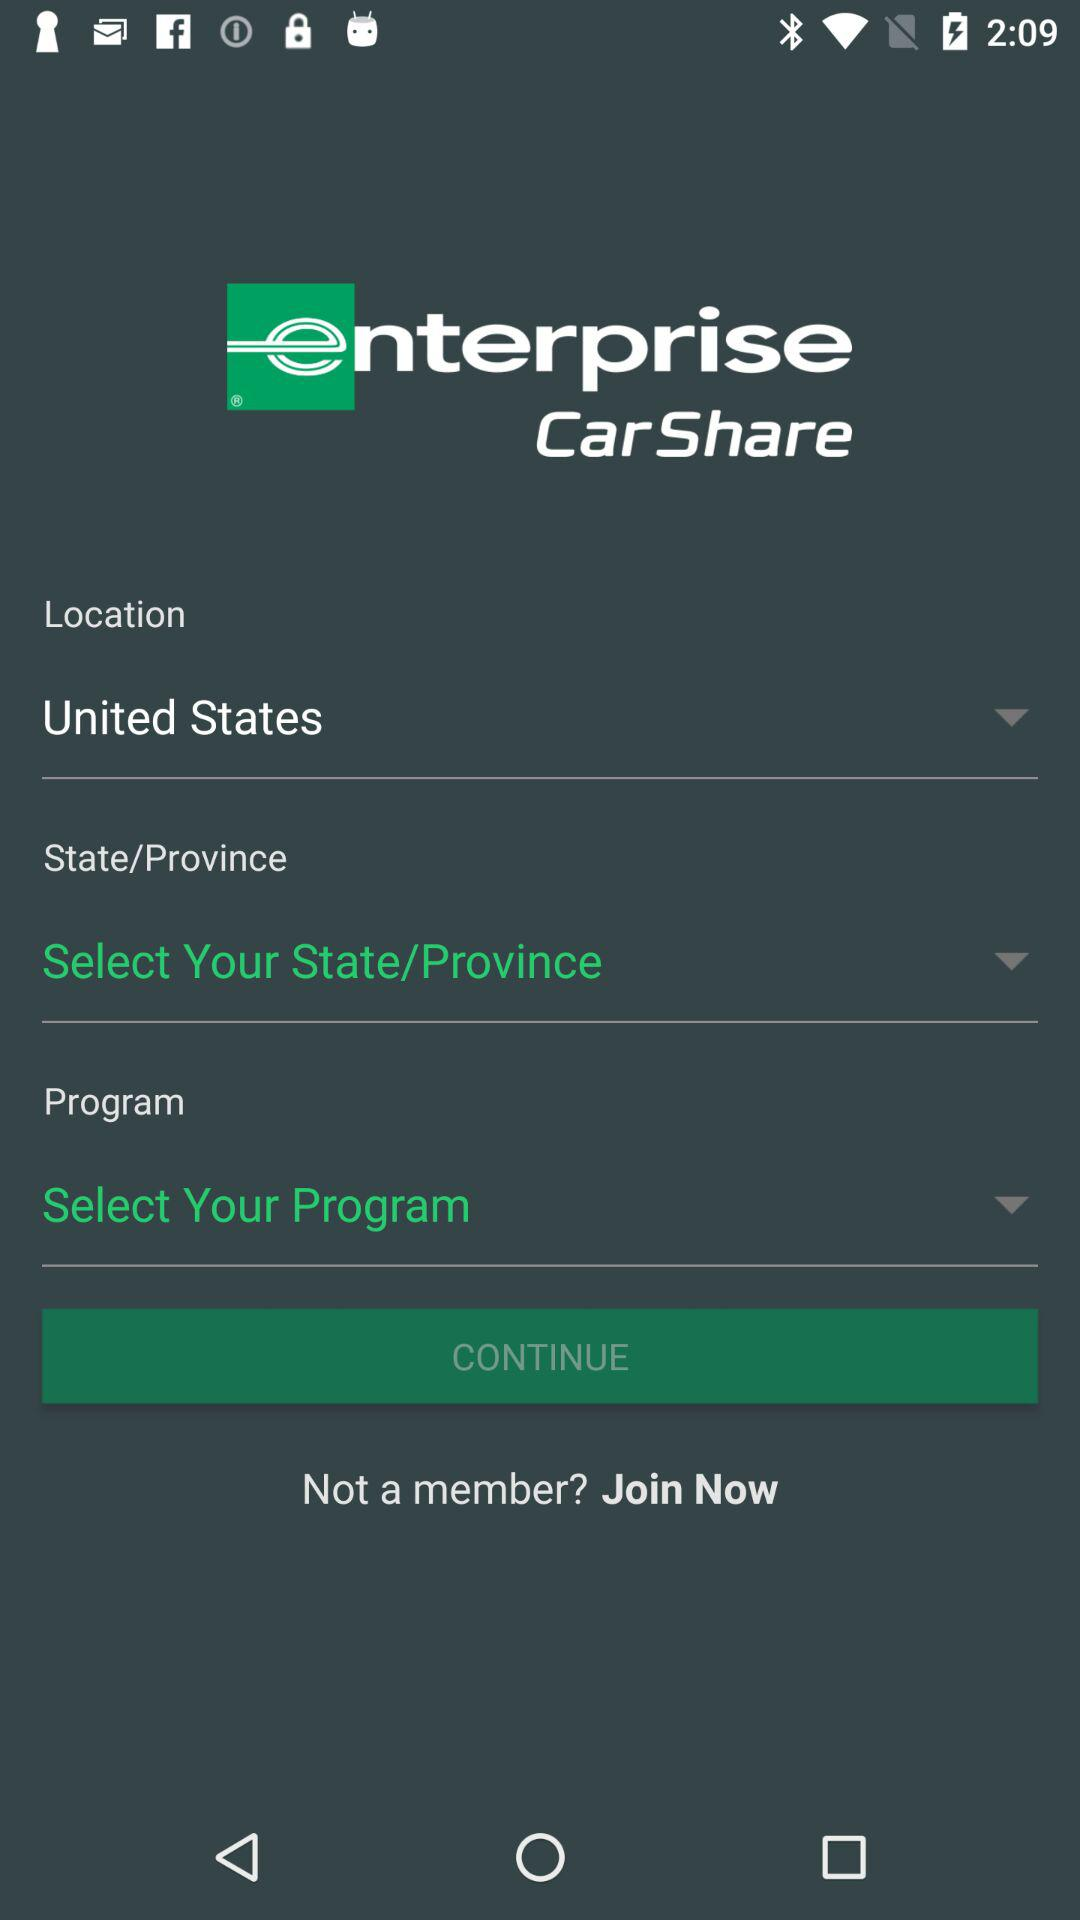What is the selected location? The selected location is the United States. 